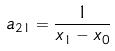<formula> <loc_0><loc_0><loc_500><loc_500>a _ { 2 1 } = \frac { 1 } { x _ { 1 } - x _ { 0 } }</formula> 